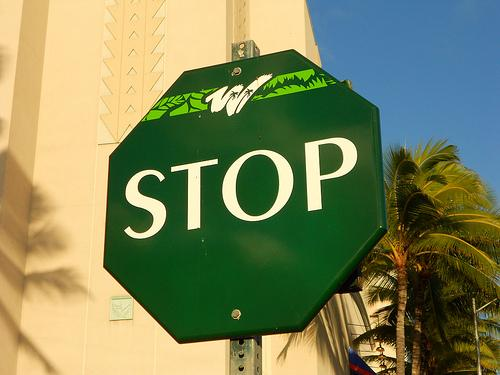Depict the arrangement of the primary objects in the photograph and their characteristics. The green stop sign with white letters and palm tree logo is in the foreground, with a pink building and green palm trees behind it. Express the visual appeal of the image, focusing on the arrangement of important elements. An eye-catching scene with a vibrant green stop sign next to a pink building, complemented by lush palm trees and crystal blue skies. Provide a brief overview of the scene captured in the image. A green stop sign with palm tree logo is adjacent to a pink building with a unique design, surrounded by palm trees beneath blue skies. Identify the main objects in the picture and their corresponding color and shape. A green octagonal stop sign, a pink rectangular building with a tan symmetrical design, and tall green palm trees. Point out the key components of the image and their respective locations. A green stop sign with white lettering on the left, a pink building on the right with a symmetrical design, and palm trees in the background. Compose a description of the atmosphere and important visual components within the image. A clear, tropical day with green palm trees and blue skies sets the backdrop for a pink building and a unique green stop sign. Describe the architecture and outdoor setting visible in the image. A tropical scene featuring a pink building with intricate design and adjacent green stop sign, surrounded by palm trees. List the significant elements present in the image and their artistic aspects. Green octagonal sign with white text, pink building with tan design, blue sky and green palm trees in the background. Describe the environment and any natural elements present in the picture. A tropical setting with clear blue sky, palm trees next to a building, and a shadow from a tree cast on the building side. Mention the central object seen in the image and its unique features. A green octagon sign with bold white lettering that says "STOP" and a palm tree logo at the top. 